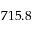<formula> <loc_0><loc_0><loc_500><loc_500>7 1 5 . 8</formula> 